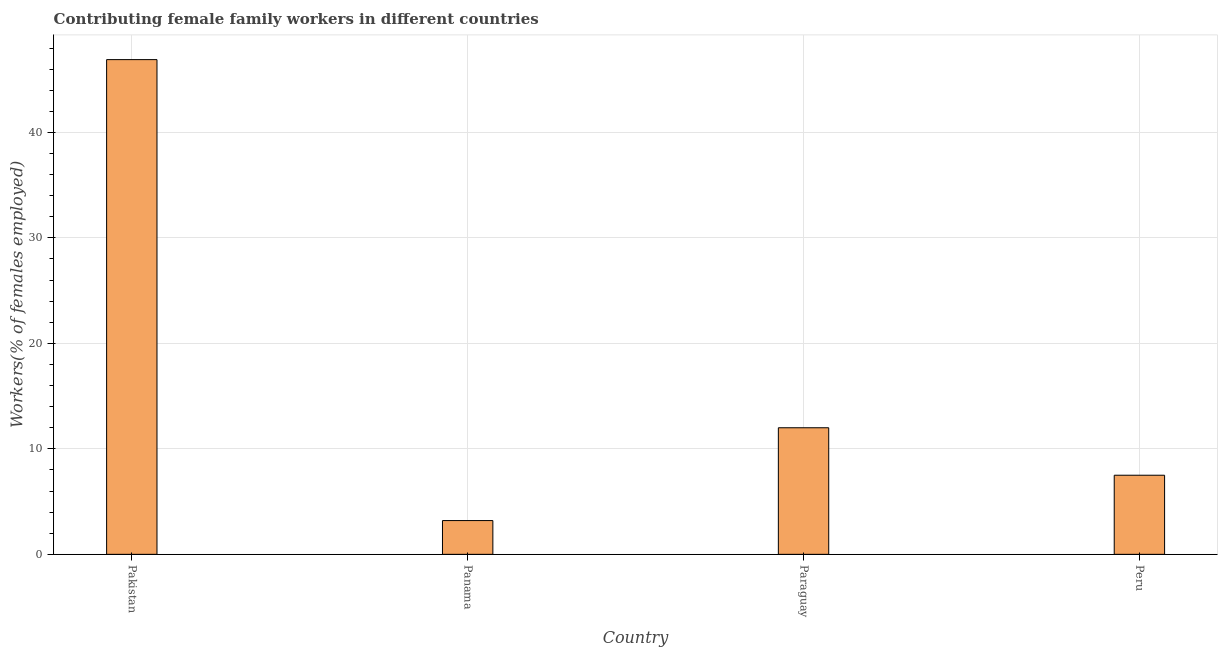Does the graph contain any zero values?
Keep it short and to the point. No. What is the title of the graph?
Keep it short and to the point. Contributing female family workers in different countries. What is the label or title of the Y-axis?
Your response must be concise. Workers(% of females employed). What is the contributing female family workers in Pakistan?
Give a very brief answer. 46.9. Across all countries, what is the maximum contributing female family workers?
Your answer should be very brief. 46.9. Across all countries, what is the minimum contributing female family workers?
Ensure brevity in your answer.  3.2. In which country was the contributing female family workers minimum?
Provide a succinct answer. Panama. What is the sum of the contributing female family workers?
Make the answer very short. 69.6. What is the difference between the contributing female family workers in Pakistan and Paraguay?
Your answer should be compact. 34.9. What is the median contributing female family workers?
Make the answer very short. 9.75. What is the ratio of the contributing female family workers in Pakistan to that in Paraguay?
Give a very brief answer. 3.91. Is the difference between the contributing female family workers in Pakistan and Peru greater than the difference between any two countries?
Your answer should be very brief. No. What is the difference between the highest and the second highest contributing female family workers?
Provide a succinct answer. 34.9. Is the sum of the contributing female family workers in Panama and Peru greater than the maximum contributing female family workers across all countries?
Ensure brevity in your answer.  No. What is the difference between the highest and the lowest contributing female family workers?
Your response must be concise. 43.7. How many countries are there in the graph?
Make the answer very short. 4. What is the difference between two consecutive major ticks on the Y-axis?
Give a very brief answer. 10. Are the values on the major ticks of Y-axis written in scientific E-notation?
Make the answer very short. No. What is the Workers(% of females employed) in Pakistan?
Your response must be concise. 46.9. What is the Workers(% of females employed) of Panama?
Offer a very short reply. 3.2. What is the difference between the Workers(% of females employed) in Pakistan and Panama?
Give a very brief answer. 43.7. What is the difference between the Workers(% of females employed) in Pakistan and Paraguay?
Your response must be concise. 34.9. What is the difference between the Workers(% of females employed) in Pakistan and Peru?
Provide a short and direct response. 39.4. What is the difference between the Workers(% of females employed) in Panama and Paraguay?
Your answer should be compact. -8.8. What is the difference between the Workers(% of females employed) in Paraguay and Peru?
Make the answer very short. 4.5. What is the ratio of the Workers(% of females employed) in Pakistan to that in Panama?
Your answer should be compact. 14.66. What is the ratio of the Workers(% of females employed) in Pakistan to that in Paraguay?
Give a very brief answer. 3.91. What is the ratio of the Workers(% of females employed) in Pakistan to that in Peru?
Keep it short and to the point. 6.25. What is the ratio of the Workers(% of females employed) in Panama to that in Paraguay?
Make the answer very short. 0.27. What is the ratio of the Workers(% of females employed) in Panama to that in Peru?
Keep it short and to the point. 0.43. 